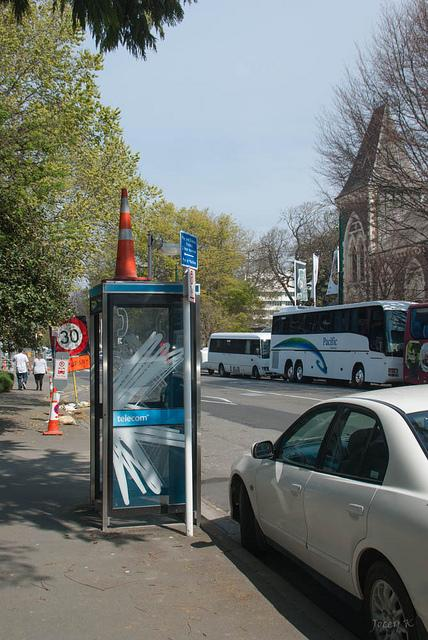Originally what was the glass booth designed for? Please explain your reasoning. phone calls. The glass booth is for phone calls. 